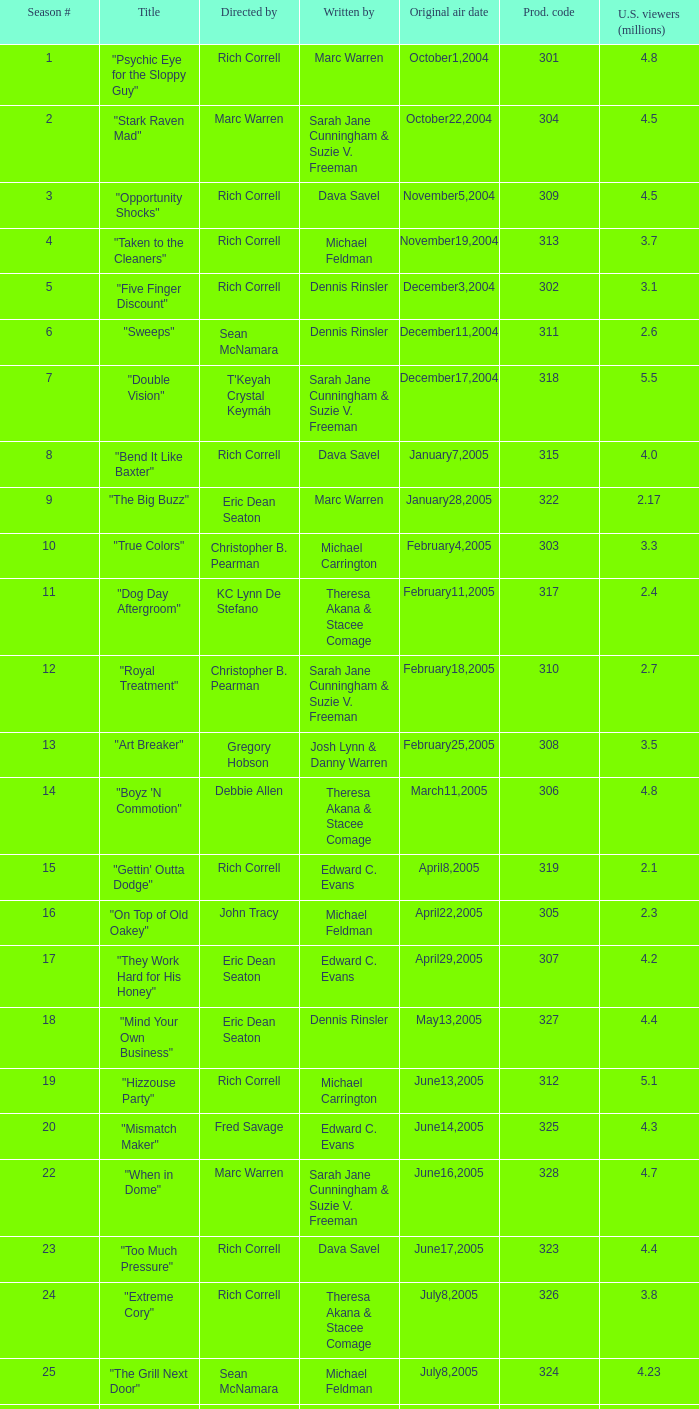What number episode of the season was titled "Vision Impossible"? 34.0. 